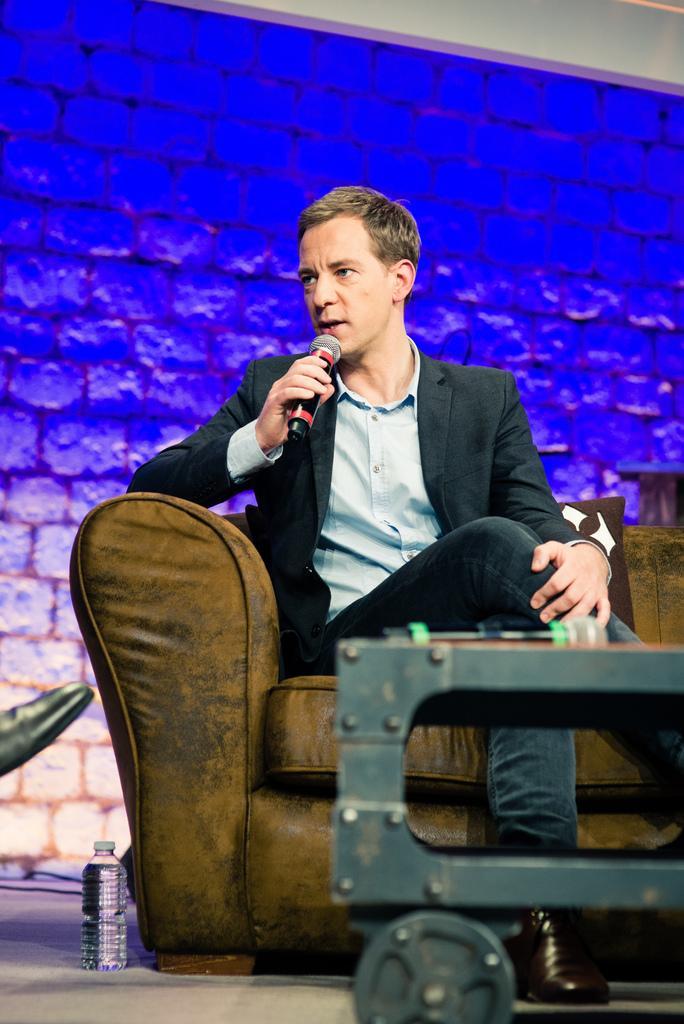Could you give a brief overview of what you see in this image? In the center we can see one man sitting on the couch and he is holding microphone. In front there is a table. In the background we can see brick wall and water bottle. 